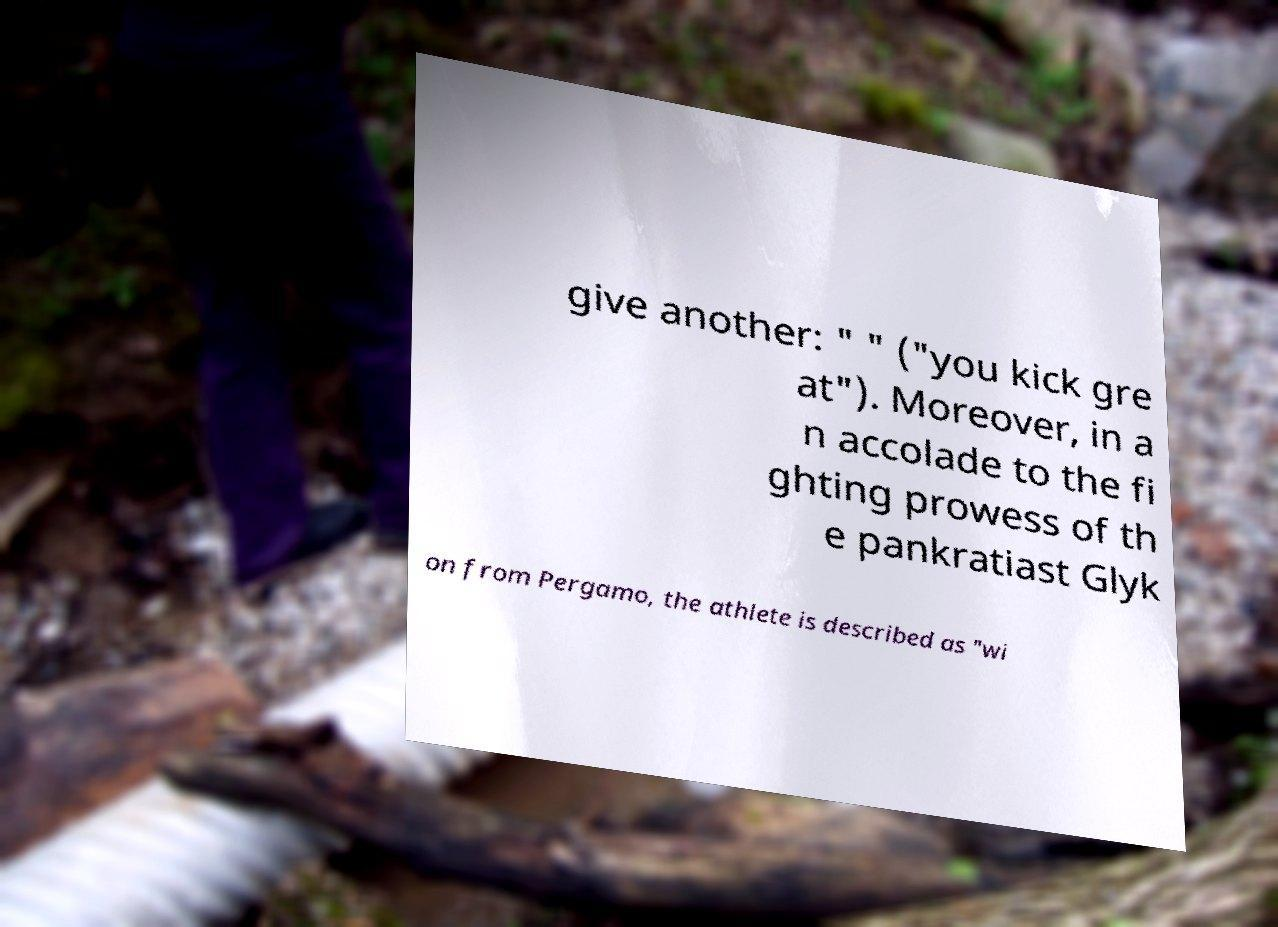Could you assist in decoding the text presented in this image and type it out clearly? give another: " " ("you kick gre at"). Moreover, in a n accolade to the fi ghting prowess of th e pankratiast Glyk on from Pergamo, the athlete is described as "wi 